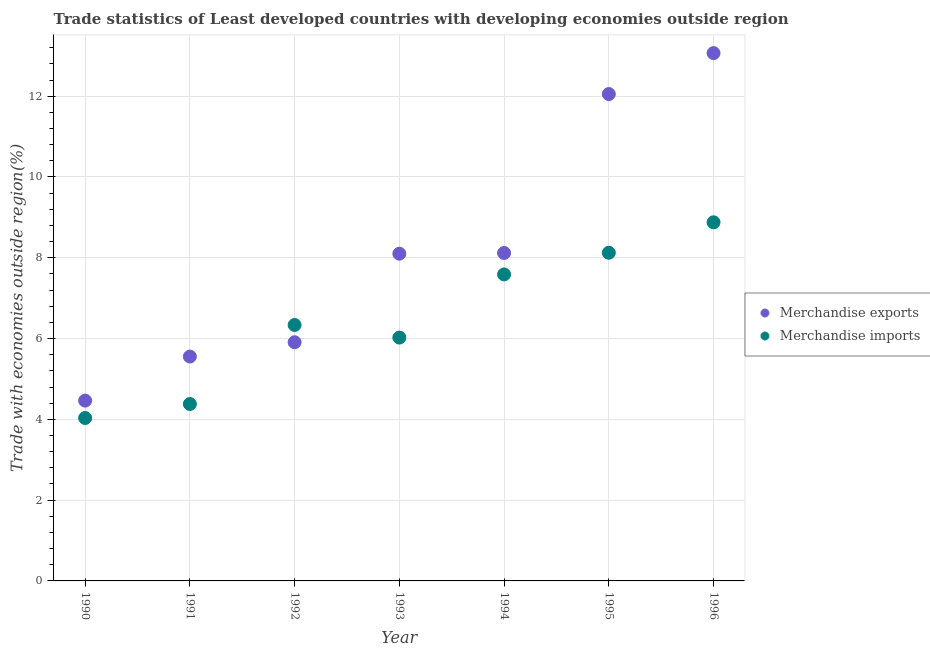What is the merchandise exports in 1995?
Offer a terse response. 12.05. Across all years, what is the maximum merchandise imports?
Your answer should be compact. 8.88. Across all years, what is the minimum merchandise imports?
Give a very brief answer. 4.03. In which year was the merchandise exports maximum?
Provide a short and direct response. 1996. What is the total merchandise exports in the graph?
Offer a terse response. 57.26. What is the difference between the merchandise imports in 1993 and that in 1995?
Offer a terse response. -2.1. What is the difference between the merchandise exports in 1994 and the merchandise imports in 1991?
Offer a very short reply. 3.74. What is the average merchandise imports per year?
Offer a terse response. 6.48. In the year 1996, what is the difference between the merchandise exports and merchandise imports?
Make the answer very short. 4.19. In how many years, is the merchandise exports greater than 2.4 %?
Keep it short and to the point. 7. What is the ratio of the merchandise exports in 1990 to that in 1993?
Your response must be concise. 0.55. Is the merchandise exports in 1990 less than that in 1995?
Give a very brief answer. Yes. What is the difference between the highest and the second highest merchandise imports?
Keep it short and to the point. 0.75. What is the difference between the highest and the lowest merchandise exports?
Offer a terse response. 8.6. In how many years, is the merchandise imports greater than the average merchandise imports taken over all years?
Your answer should be compact. 3. How many dotlines are there?
Ensure brevity in your answer.  2. Where does the legend appear in the graph?
Offer a very short reply. Center right. How are the legend labels stacked?
Ensure brevity in your answer.  Vertical. What is the title of the graph?
Offer a terse response. Trade statistics of Least developed countries with developing economies outside region. What is the label or title of the X-axis?
Your answer should be very brief. Year. What is the label or title of the Y-axis?
Make the answer very short. Trade with economies outside region(%). What is the Trade with economies outside region(%) in Merchandise exports in 1990?
Keep it short and to the point. 4.46. What is the Trade with economies outside region(%) in Merchandise imports in 1990?
Make the answer very short. 4.03. What is the Trade with economies outside region(%) of Merchandise exports in 1991?
Keep it short and to the point. 5.55. What is the Trade with economies outside region(%) of Merchandise imports in 1991?
Offer a terse response. 4.38. What is the Trade with economies outside region(%) of Merchandise exports in 1992?
Make the answer very short. 5.91. What is the Trade with economies outside region(%) of Merchandise imports in 1992?
Offer a very short reply. 6.34. What is the Trade with economies outside region(%) in Merchandise exports in 1993?
Offer a very short reply. 8.1. What is the Trade with economies outside region(%) in Merchandise imports in 1993?
Keep it short and to the point. 6.02. What is the Trade with economies outside region(%) in Merchandise exports in 1994?
Offer a very short reply. 8.12. What is the Trade with economies outside region(%) in Merchandise imports in 1994?
Make the answer very short. 7.59. What is the Trade with economies outside region(%) of Merchandise exports in 1995?
Make the answer very short. 12.05. What is the Trade with economies outside region(%) in Merchandise imports in 1995?
Provide a short and direct response. 8.12. What is the Trade with economies outside region(%) of Merchandise exports in 1996?
Offer a terse response. 13.07. What is the Trade with economies outside region(%) of Merchandise imports in 1996?
Make the answer very short. 8.88. Across all years, what is the maximum Trade with economies outside region(%) of Merchandise exports?
Offer a terse response. 13.07. Across all years, what is the maximum Trade with economies outside region(%) of Merchandise imports?
Give a very brief answer. 8.88. Across all years, what is the minimum Trade with economies outside region(%) in Merchandise exports?
Ensure brevity in your answer.  4.46. Across all years, what is the minimum Trade with economies outside region(%) of Merchandise imports?
Offer a terse response. 4.03. What is the total Trade with economies outside region(%) in Merchandise exports in the graph?
Keep it short and to the point. 57.26. What is the total Trade with economies outside region(%) of Merchandise imports in the graph?
Give a very brief answer. 45.36. What is the difference between the Trade with economies outside region(%) of Merchandise exports in 1990 and that in 1991?
Your answer should be compact. -1.09. What is the difference between the Trade with economies outside region(%) of Merchandise imports in 1990 and that in 1991?
Keep it short and to the point. -0.35. What is the difference between the Trade with economies outside region(%) in Merchandise exports in 1990 and that in 1992?
Your response must be concise. -1.44. What is the difference between the Trade with economies outside region(%) of Merchandise imports in 1990 and that in 1992?
Ensure brevity in your answer.  -2.3. What is the difference between the Trade with economies outside region(%) in Merchandise exports in 1990 and that in 1993?
Ensure brevity in your answer.  -3.64. What is the difference between the Trade with economies outside region(%) of Merchandise imports in 1990 and that in 1993?
Ensure brevity in your answer.  -1.99. What is the difference between the Trade with economies outside region(%) of Merchandise exports in 1990 and that in 1994?
Offer a very short reply. -3.65. What is the difference between the Trade with economies outside region(%) in Merchandise imports in 1990 and that in 1994?
Provide a succinct answer. -3.55. What is the difference between the Trade with economies outside region(%) of Merchandise exports in 1990 and that in 1995?
Keep it short and to the point. -7.59. What is the difference between the Trade with economies outside region(%) of Merchandise imports in 1990 and that in 1995?
Your answer should be compact. -4.09. What is the difference between the Trade with economies outside region(%) of Merchandise exports in 1990 and that in 1996?
Your answer should be compact. -8.6. What is the difference between the Trade with economies outside region(%) in Merchandise imports in 1990 and that in 1996?
Offer a terse response. -4.84. What is the difference between the Trade with economies outside region(%) of Merchandise exports in 1991 and that in 1992?
Keep it short and to the point. -0.35. What is the difference between the Trade with economies outside region(%) of Merchandise imports in 1991 and that in 1992?
Your response must be concise. -1.96. What is the difference between the Trade with economies outside region(%) of Merchandise exports in 1991 and that in 1993?
Make the answer very short. -2.55. What is the difference between the Trade with economies outside region(%) of Merchandise imports in 1991 and that in 1993?
Keep it short and to the point. -1.64. What is the difference between the Trade with economies outside region(%) of Merchandise exports in 1991 and that in 1994?
Make the answer very short. -2.56. What is the difference between the Trade with economies outside region(%) in Merchandise imports in 1991 and that in 1994?
Offer a terse response. -3.21. What is the difference between the Trade with economies outside region(%) in Merchandise exports in 1991 and that in 1995?
Provide a succinct answer. -6.5. What is the difference between the Trade with economies outside region(%) of Merchandise imports in 1991 and that in 1995?
Offer a very short reply. -3.74. What is the difference between the Trade with economies outside region(%) in Merchandise exports in 1991 and that in 1996?
Provide a succinct answer. -7.51. What is the difference between the Trade with economies outside region(%) of Merchandise imports in 1991 and that in 1996?
Keep it short and to the point. -4.5. What is the difference between the Trade with economies outside region(%) in Merchandise exports in 1992 and that in 1993?
Ensure brevity in your answer.  -2.19. What is the difference between the Trade with economies outside region(%) of Merchandise imports in 1992 and that in 1993?
Provide a succinct answer. 0.31. What is the difference between the Trade with economies outside region(%) of Merchandise exports in 1992 and that in 1994?
Make the answer very short. -2.21. What is the difference between the Trade with economies outside region(%) of Merchandise imports in 1992 and that in 1994?
Provide a short and direct response. -1.25. What is the difference between the Trade with economies outside region(%) in Merchandise exports in 1992 and that in 1995?
Give a very brief answer. -6.14. What is the difference between the Trade with economies outside region(%) in Merchandise imports in 1992 and that in 1995?
Give a very brief answer. -1.79. What is the difference between the Trade with economies outside region(%) of Merchandise exports in 1992 and that in 1996?
Offer a very short reply. -7.16. What is the difference between the Trade with economies outside region(%) in Merchandise imports in 1992 and that in 1996?
Provide a succinct answer. -2.54. What is the difference between the Trade with economies outside region(%) of Merchandise exports in 1993 and that in 1994?
Your response must be concise. -0.02. What is the difference between the Trade with economies outside region(%) of Merchandise imports in 1993 and that in 1994?
Offer a terse response. -1.56. What is the difference between the Trade with economies outside region(%) in Merchandise exports in 1993 and that in 1995?
Make the answer very short. -3.95. What is the difference between the Trade with economies outside region(%) in Merchandise imports in 1993 and that in 1995?
Provide a succinct answer. -2.1. What is the difference between the Trade with economies outside region(%) in Merchandise exports in 1993 and that in 1996?
Keep it short and to the point. -4.97. What is the difference between the Trade with economies outside region(%) in Merchandise imports in 1993 and that in 1996?
Make the answer very short. -2.85. What is the difference between the Trade with economies outside region(%) in Merchandise exports in 1994 and that in 1995?
Give a very brief answer. -3.93. What is the difference between the Trade with economies outside region(%) in Merchandise imports in 1994 and that in 1995?
Provide a short and direct response. -0.54. What is the difference between the Trade with economies outside region(%) in Merchandise exports in 1994 and that in 1996?
Offer a very short reply. -4.95. What is the difference between the Trade with economies outside region(%) in Merchandise imports in 1994 and that in 1996?
Provide a succinct answer. -1.29. What is the difference between the Trade with economies outside region(%) of Merchandise exports in 1995 and that in 1996?
Keep it short and to the point. -1.01. What is the difference between the Trade with economies outside region(%) of Merchandise imports in 1995 and that in 1996?
Your answer should be very brief. -0.75. What is the difference between the Trade with economies outside region(%) of Merchandise exports in 1990 and the Trade with economies outside region(%) of Merchandise imports in 1991?
Offer a terse response. 0.08. What is the difference between the Trade with economies outside region(%) in Merchandise exports in 1990 and the Trade with economies outside region(%) in Merchandise imports in 1992?
Your answer should be very brief. -1.87. What is the difference between the Trade with economies outside region(%) of Merchandise exports in 1990 and the Trade with economies outside region(%) of Merchandise imports in 1993?
Provide a short and direct response. -1.56. What is the difference between the Trade with economies outside region(%) in Merchandise exports in 1990 and the Trade with economies outside region(%) in Merchandise imports in 1994?
Your answer should be very brief. -3.12. What is the difference between the Trade with economies outside region(%) in Merchandise exports in 1990 and the Trade with economies outside region(%) in Merchandise imports in 1995?
Your response must be concise. -3.66. What is the difference between the Trade with economies outside region(%) in Merchandise exports in 1990 and the Trade with economies outside region(%) in Merchandise imports in 1996?
Your answer should be compact. -4.41. What is the difference between the Trade with economies outside region(%) in Merchandise exports in 1991 and the Trade with economies outside region(%) in Merchandise imports in 1992?
Your answer should be compact. -0.78. What is the difference between the Trade with economies outside region(%) in Merchandise exports in 1991 and the Trade with economies outside region(%) in Merchandise imports in 1993?
Your answer should be very brief. -0.47. What is the difference between the Trade with economies outside region(%) of Merchandise exports in 1991 and the Trade with economies outside region(%) of Merchandise imports in 1994?
Offer a terse response. -2.03. What is the difference between the Trade with economies outside region(%) of Merchandise exports in 1991 and the Trade with economies outside region(%) of Merchandise imports in 1995?
Your response must be concise. -2.57. What is the difference between the Trade with economies outside region(%) in Merchandise exports in 1991 and the Trade with economies outside region(%) in Merchandise imports in 1996?
Your answer should be compact. -3.32. What is the difference between the Trade with economies outside region(%) in Merchandise exports in 1992 and the Trade with economies outside region(%) in Merchandise imports in 1993?
Provide a short and direct response. -0.12. What is the difference between the Trade with economies outside region(%) of Merchandise exports in 1992 and the Trade with economies outside region(%) of Merchandise imports in 1994?
Your answer should be compact. -1.68. What is the difference between the Trade with economies outside region(%) in Merchandise exports in 1992 and the Trade with economies outside region(%) in Merchandise imports in 1995?
Provide a succinct answer. -2.22. What is the difference between the Trade with economies outside region(%) in Merchandise exports in 1992 and the Trade with economies outside region(%) in Merchandise imports in 1996?
Your response must be concise. -2.97. What is the difference between the Trade with economies outside region(%) in Merchandise exports in 1993 and the Trade with economies outside region(%) in Merchandise imports in 1994?
Keep it short and to the point. 0.51. What is the difference between the Trade with economies outside region(%) in Merchandise exports in 1993 and the Trade with economies outside region(%) in Merchandise imports in 1995?
Your answer should be very brief. -0.02. What is the difference between the Trade with economies outside region(%) in Merchandise exports in 1993 and the Trade with economies outside region(%) in Merchandise imports in 1996?
Give a very brief answer. -0.78. What is the difference between the Trade with economies outside region(%) in Merchandise exports in 1994 and the Trade with economies outside region(%) in Merchandise imports in 1995?
Offer a terse response. -0.01. What is the difference between the Trade with economies outside region(%) of Merchandise exports in 1994 and the Trade with economies outside region(%) of Merchandise imports in 1996?
Your answer should be compact. -0.76. What is the difference between the Trade with economies outside region(%) of Merchandise exports in 1995 and the Trade with economies outside region(%) of Merchandise imports in 1996?
Give a very brief answer. 3.17. What is the average Trade with economies outside region(%) in Merchandise exports per year?
Your answer should be compact. 8.18. What is the average Trade with economies outside region(%) of Merchandise imports per year?
Keep it short and to the point. 6.48. In the year 1990, what is the difference between the Trade with economies outside region(%) in Merchandise exports and Trade with economies outside region(%) in Merchandise imports?
Give a very brief answer. 0.43. In the year 1991, what is the difference between the Trade with economies outside region(%) of Merchandise exports and Trade with economies outside region(%) of Merchandise imports?
Offer a terse response. 1.17. In the year 1992, what is the difference between the Trade with economies outside region(%) in Merchandise exports and Trade with economies outside region(%) in Merchandise imports?
Provide a succinct answer. -0.43. In the year 1993, what is the difference between the Trade with economies outside region(%) in Merchandise exports and Trade with economies outside region(%) in Merchandise imports?
Provide a succinct answer. 2.08. In the year 1994, what is the difference between the Trade with economies outside region(%) in Merchandise exports and Trade with economies outside region(%) in Merchandise imports?
Give a very brief answer. 0.53. In the year 1995, what is the difference between the Trade with economies outside region(%) of Merchandise exports and Trade with economies outside region(%) of Merchandise imports?
Your response must be concise. 3.93. In the year 1996, what is the difference between the Trade with economies outside region(%) of Merchandise exports and Trade with economies outside region(%) of Merchandise imports?
Offer a very short reply. 4.19. What is the ratio of the Trade with economies outside region(%) of Merchandise exports in 1990 to that in 1991?
Provide a succinct answer. 0.8. What is the ratio of the Trade with economies outside region(%) of Merchandise imports in 1990 to that in 1991?
Ensure brevity in your answer.  0.92. What is the ratio of the Trade with economies outside region(%) of Merchandise exports in 1990 to that in 1992?
Offer a terse response. 0.76. What is the ratio of the Trade with economies outside region(%) in Merchandise imports in 1990 to that in 1992?
Offer a very short reply. 0.64. What is the ratio of the Trade with economies outside region(%) in Merchandise exports in 1990 to that in 1993?
Give a very brief answer. 0.55. What is the ratio of the Trade with economies outside region(%) in Merchandise imports in 1990 to that in 1993?
Offer a terse response. 0.67. What is the ratio of the Trade with economies outside region(%) of Merchandise exports in 1990 to that in 1994?
Make the answer very short. 0.55. What is the ratio of the Trade with economies outside region(%) in Merchandise imports in 1990 to that in 1994?
Your answer should be very brief. 0.53. What is the ratio of the Trade with economies outside region(%) of Merchandise exports in 1990 to that in 1995?
Your answer should be very brief. 0.37. What is the ratio of the Trade with economies outside region(%) in Merchandise imports in 1990 to that in 1995?
Your answer should be very brief. 0.5. What is the ratio of the Trade with economies outside region(%) in Merchandise exports in 1990 to that in 1996?
Ensure brevity in your answer.  0.34. What is the ratio of the Trade with economies outside region(%) in Merchandise imports in 1990 to that in 1996?
Offer a very short reply. 0.45. What is the ratio of the Trade with economies outside region(%) in Merchandise exports in 1991 to that in 1992?
Your response must be concise. 0.94. What is the ratio of the Trade with economies outside region(%) in Merchandise imports in 1991 to that in 1992?
Ensure brevity in your answer.  0.69. What is the ratio of the Trade with economies outside region(%) of Merchandise exports in 1991 to that in 1993?
Keep it short and to the point. 0.69. What is the ratio of the Trade with economies outside region(%) in Merchandise imports in 1991 to that in 1993?
Provide a short and direct response. 0.73. What is the ratio of the Trade with economies outside region(%) of Merchandise exports in 1991 to that in 1994?
Ensure brevity in your answer.  0.68. What is the ratio of the Trade with economies outside region(%) of Merchandise imports in 1991 to that in 1994?
Offer a very short reply. 0.58. What is the ratio of the Trade with economies outside region(%) in Merchandise exports in 1991 to that in 1995?
Provide a short and direct response. 0.46. What is the ratio of the Trade with economies outside region(%) in Merchandise imports in 1991 to that in 1995?
Your answer should be compact. 0.54. What is the ratio of the Trade with economies outside region(%) in Merchandise exports in 1991 to that in 1996?
Your response must be concise. 0.43. What is the ratio of the Trade with economies outside region(%) of Merchandise imports in 1991 to that in 1996?
Make the answer very short. 0.49. What is the ratio of the Trade with economies outside region(%) in Merchandise exports in 1992 to that in 1993?
Make the answer very short. 0.73. What is the ratio of the Trade with economies outside region(%) in Merchandise imports in 1992 to that in 1993?
Your response must be concise. 1.05. What is the ratio of the Trade with economies outside region(%) in Merchandise exports in 1992 to that in 1994?
Your answer should be very brief. 0.73. What is the ratio of the Trade with economies outside region(%) in Merchandise imports in 1992 to that in 1994?
Ensure brevity in your answer.  0.83. What is the ratio of the Trade with economies outside region(%) in Merchandise exports in 1992 to that in 1995?
Provide a short and direct response. 0.49. What is the ratio of the Trade with economies outside region(%) of Merchandise imports in 1992 to that in 1995?
Your answer should be very brief. 0.78. What is the ratio of the Trade with economies outside region(%) of Merchandise exports in 1992 to that in 1996?
Offer a very short reply. 0.45. What is the ratio of the Trade with economies outside region(%) in Merchandise imports in 1992 to that in 1996?
Offer a very short reply. 0.71. What is the ratio of the Trade with economies outside region(%) of Merchandise exports in 1993 to that in 1994?
Make the answer very short. 1. What is the ratio of the Trade with economies outside region(%) of Merchandise imports in 1993 to that in 1994?
Keep it short and to the point. 0.79. What is the ratio of the Trade with economies outside region(%) of Merchandise exports in 1993 to that in 1995?
Offer a very short reply. 0.67. What is the ratio of the Trade with economies outside region(%) in Merchandise imports in 1993 to that in 1995?
Give a very brief answer. 0.74. What is the ratio of the Trade with economies outside region(%) of Merchandise exports in 1993 to that in 1996?
Your answer should be compact. 0.62. What is the ratio of the Trade with economies outside region(%) in Merchandise imports in 1993 to that in 1996?
Keep it short and to the point. 0.68. What is the ratio of the Trade with economies outside region(%) of Merchandise exports in 1994 to that in 1995?
Offer a very short reply. 0.67. What is the ratio of the Trade with economies outside region(%) in Merchandise imports in 1994 to that in 1995?
Offer a terse response. 0.93. What is the ratio of the Trade with economies outside region(%) of Merchandise exports in 1994 to that in 1996?
Give a very brief answer. 0.62. What is the ratio of the Trade with economies outside region(%) of Merchandise imports in 1994 to that in 1996?
Offer a terse response. 0.85. What is the ratio of the Trade with economies outside region(%) in Merchandise exports in 1995 to that in 1996?
Offer a very short reply. 0.92. What is the ratio of the Trade with economies outside region(%) in Merchandise imports in 1995 to that in 1996?
Your response must be concise. 0.92. What is the difference between the highest and the second highest Trade with economies outside region(%) of Merchandise exports?
Offer a very short reply. 1.01. What is the difference between the highest and the second highest Trade with economies outside region(%) of Merchandise imports?
Give a very brief answer. 0.75. What is the difference between the highest and the lowest Trade with economies outside region(%) of Merchandise exports?
Your response must be concise. 8.6. What is the difference between the highest and the lowest Trade with economies outside region(%) in Merchandise imports?
Your response must be concise. 4.84. 